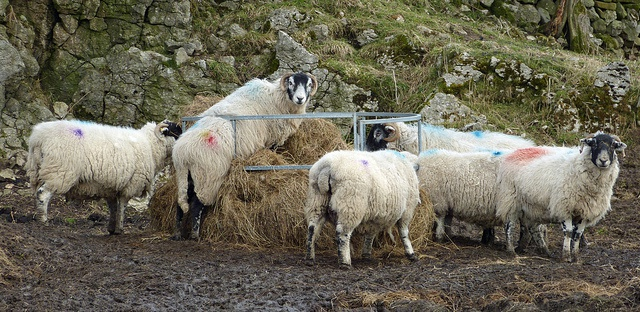Describe the objects in this image and their specific colors. I can see sheep in gray, darkgray, lightgray, and black tones, sheep in gray, lightgray, and darkgray tones, sheep in gray, darkgray, lightgray, and black tones, sheep in gray, ivory, darkgray, and black tones, and sheep in gray, darkgray, black, and lightgray tones in this image. 